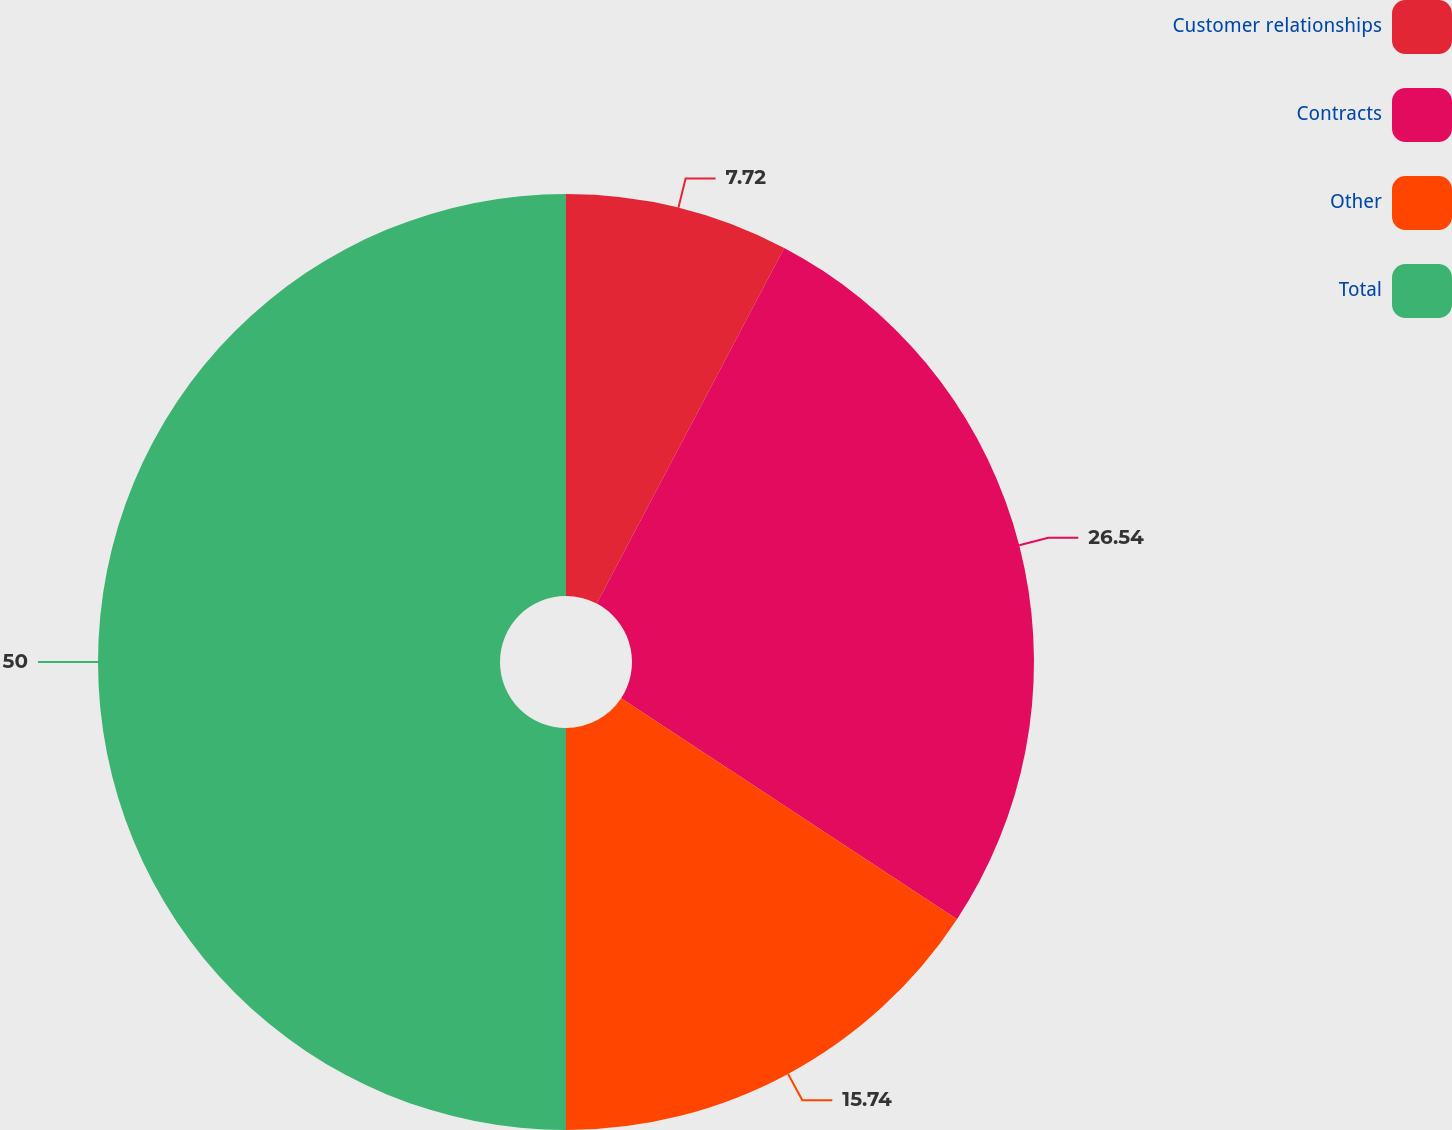Convert chart. <chart><loc_0><loc_0><loc_500><loc_500><pie_chart><fcel>Customer relationships<fcel>Contracts<fcel>Other<fcel>Total<nl><fcel>7.72%<fcel>26.54%<fcel>15.74%<fcel>50.0%<nl></chart> 